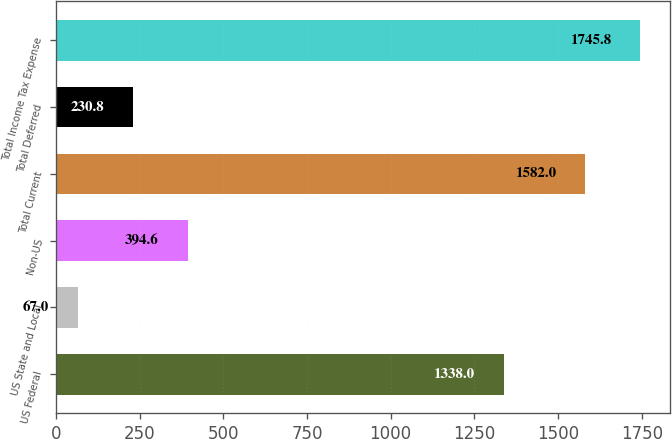Convert chart to OTSL. <chart><loc_0><loc_0><loc_500><loc_500><bar_chart><fcel>US Federal<fcel>US State and Local<fcel>Non-US<fcel>Total Current<fcel>Total Deferred<fcel>Total Income Tax Expense<nl><fcel>1338<fcel>67<fcel>394.6<fcel>1582<fcel>230.8<fcel>1745.8<nl></chart> 